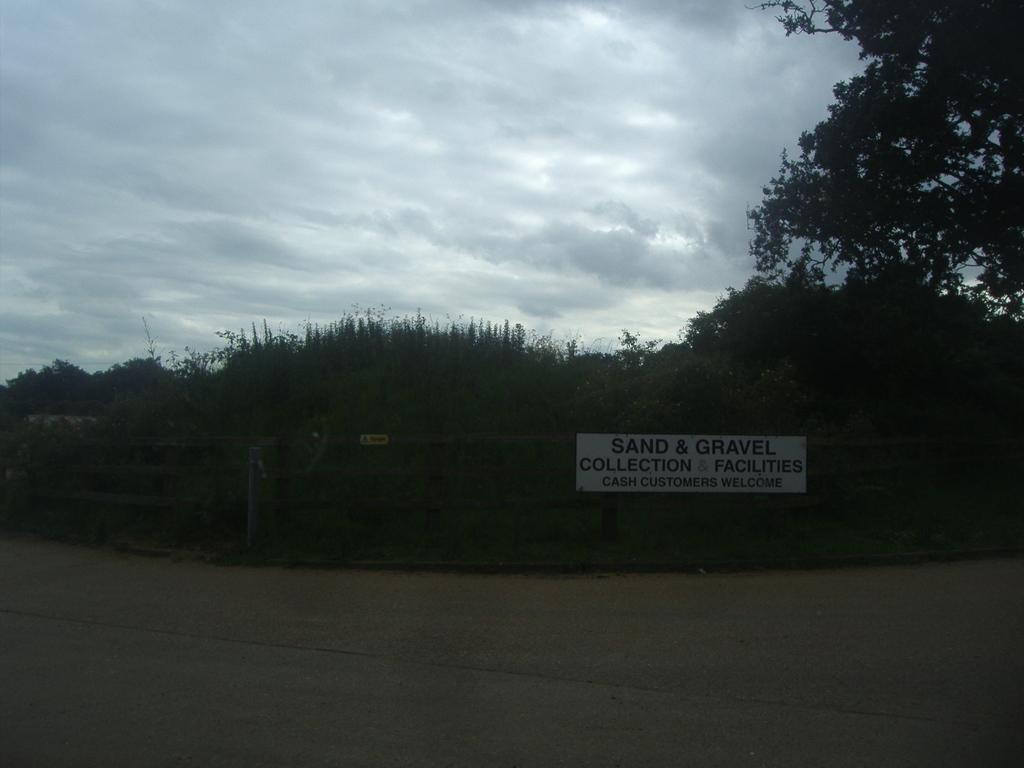What is the main feature of the image? There is a road in the image. What can be seen in the background of the image? There is a fence, a board, trees, and the sky visible in the background of the image. How much sugar is being mined in the image? There is no mention of sugar or mining in the image; it features a road and background elements. 